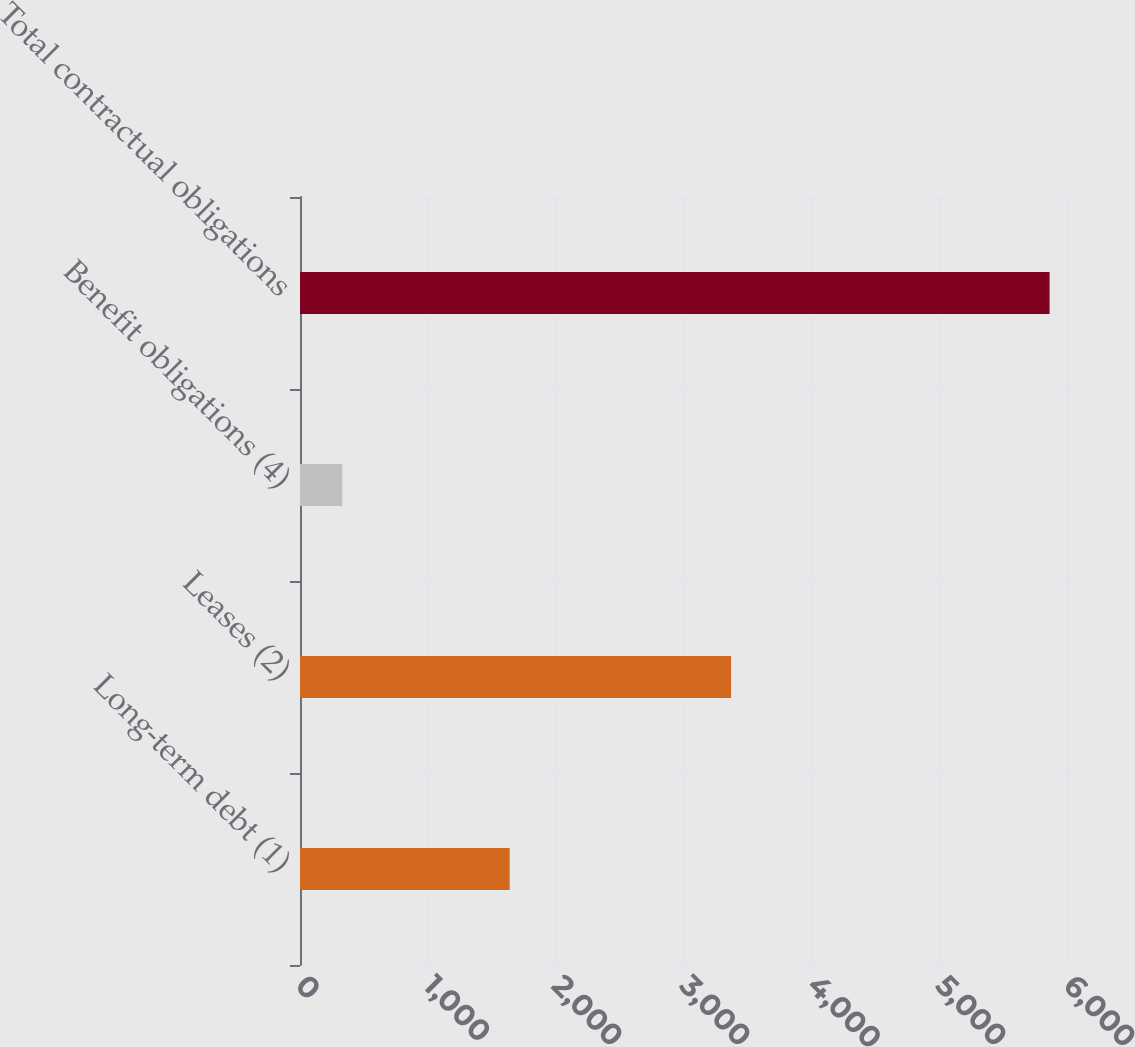Convert chart to OTSL. <chart><loc_0><loc_0><loc_500><loc_500><bar_chart><fcel>Long-term debt (1)<fcel>Leases (2)<fcel>Benefit obligations (4)<fcel>Total contractual obligations<nl><fcel>1638<fcel>3367.7<fcel>330.3<fcel>5856<nl></chart> 